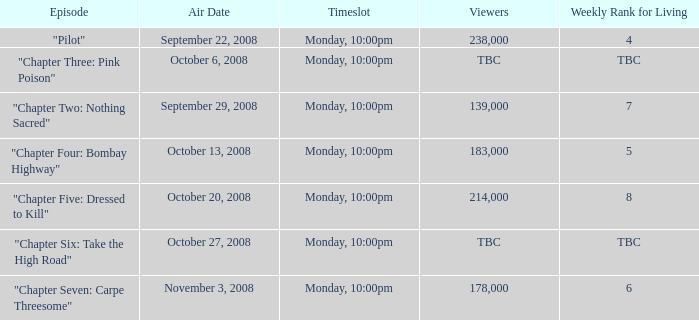What is the episode with the 183,000 viewers? "Chapter Four: Bombay Highway". 